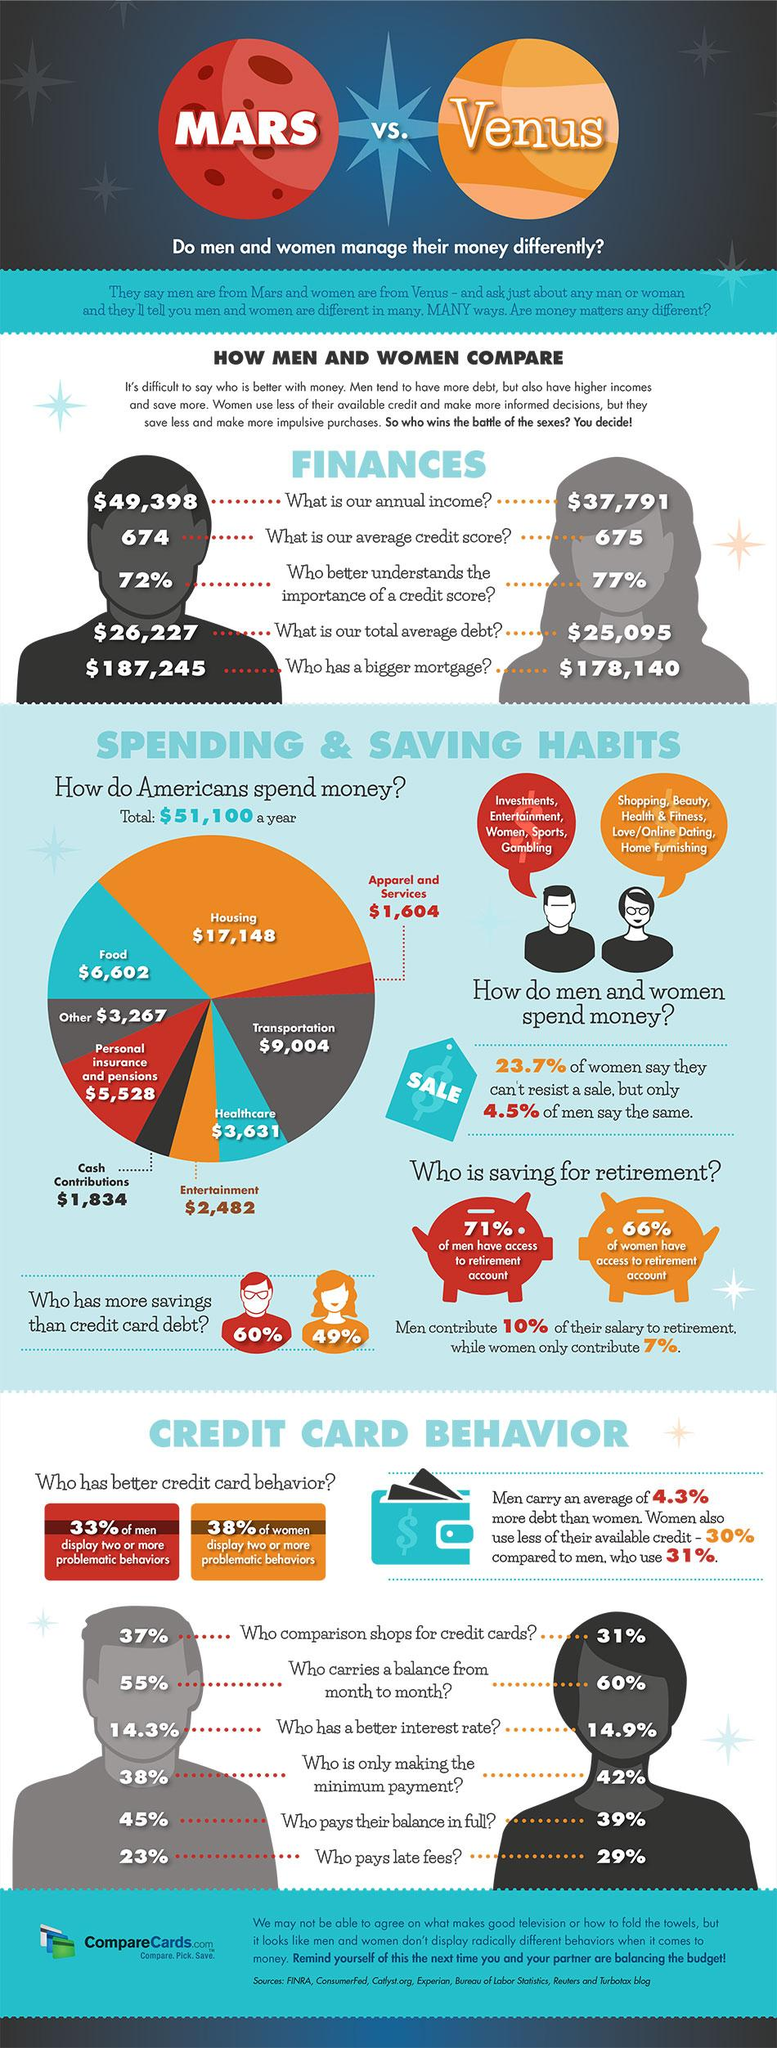Outline some significant characteristics in this image. According to a recent survey, 45% of American men pay their full credit card balance each month. A recent survey has shown that 72% of American men understand the importance of a credit score. In the United States, housing is the sector in which Americans typically spend the most money. According to a recent survey, 42% of American women only make the minimum credit card payments. According to a recent survey, 49% of American women have savings that exceed their credit card debts. 